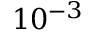<formula> <loc_0><loc_0><loc_500><loc_500>1 0 ^ { - 3 }</formula> 